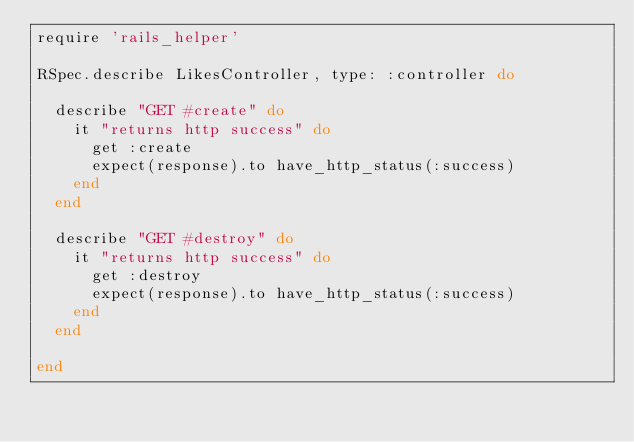<code> <loc_0><loc_0><loc_500><loc_500><_Ruby_>require 'rails_helper'

RSpec.describe LikesController, type: :controller do

  describe "GET #create" do
    it "returns http success" do
      get :create
      expect(response).to have_http_status(:success)
    end
  end

  describe "GET #destroy" do
    it "returns http success" do
      get :destroy
      expect(response).to have_http_status(:success)
    end
  end

end
</code> 